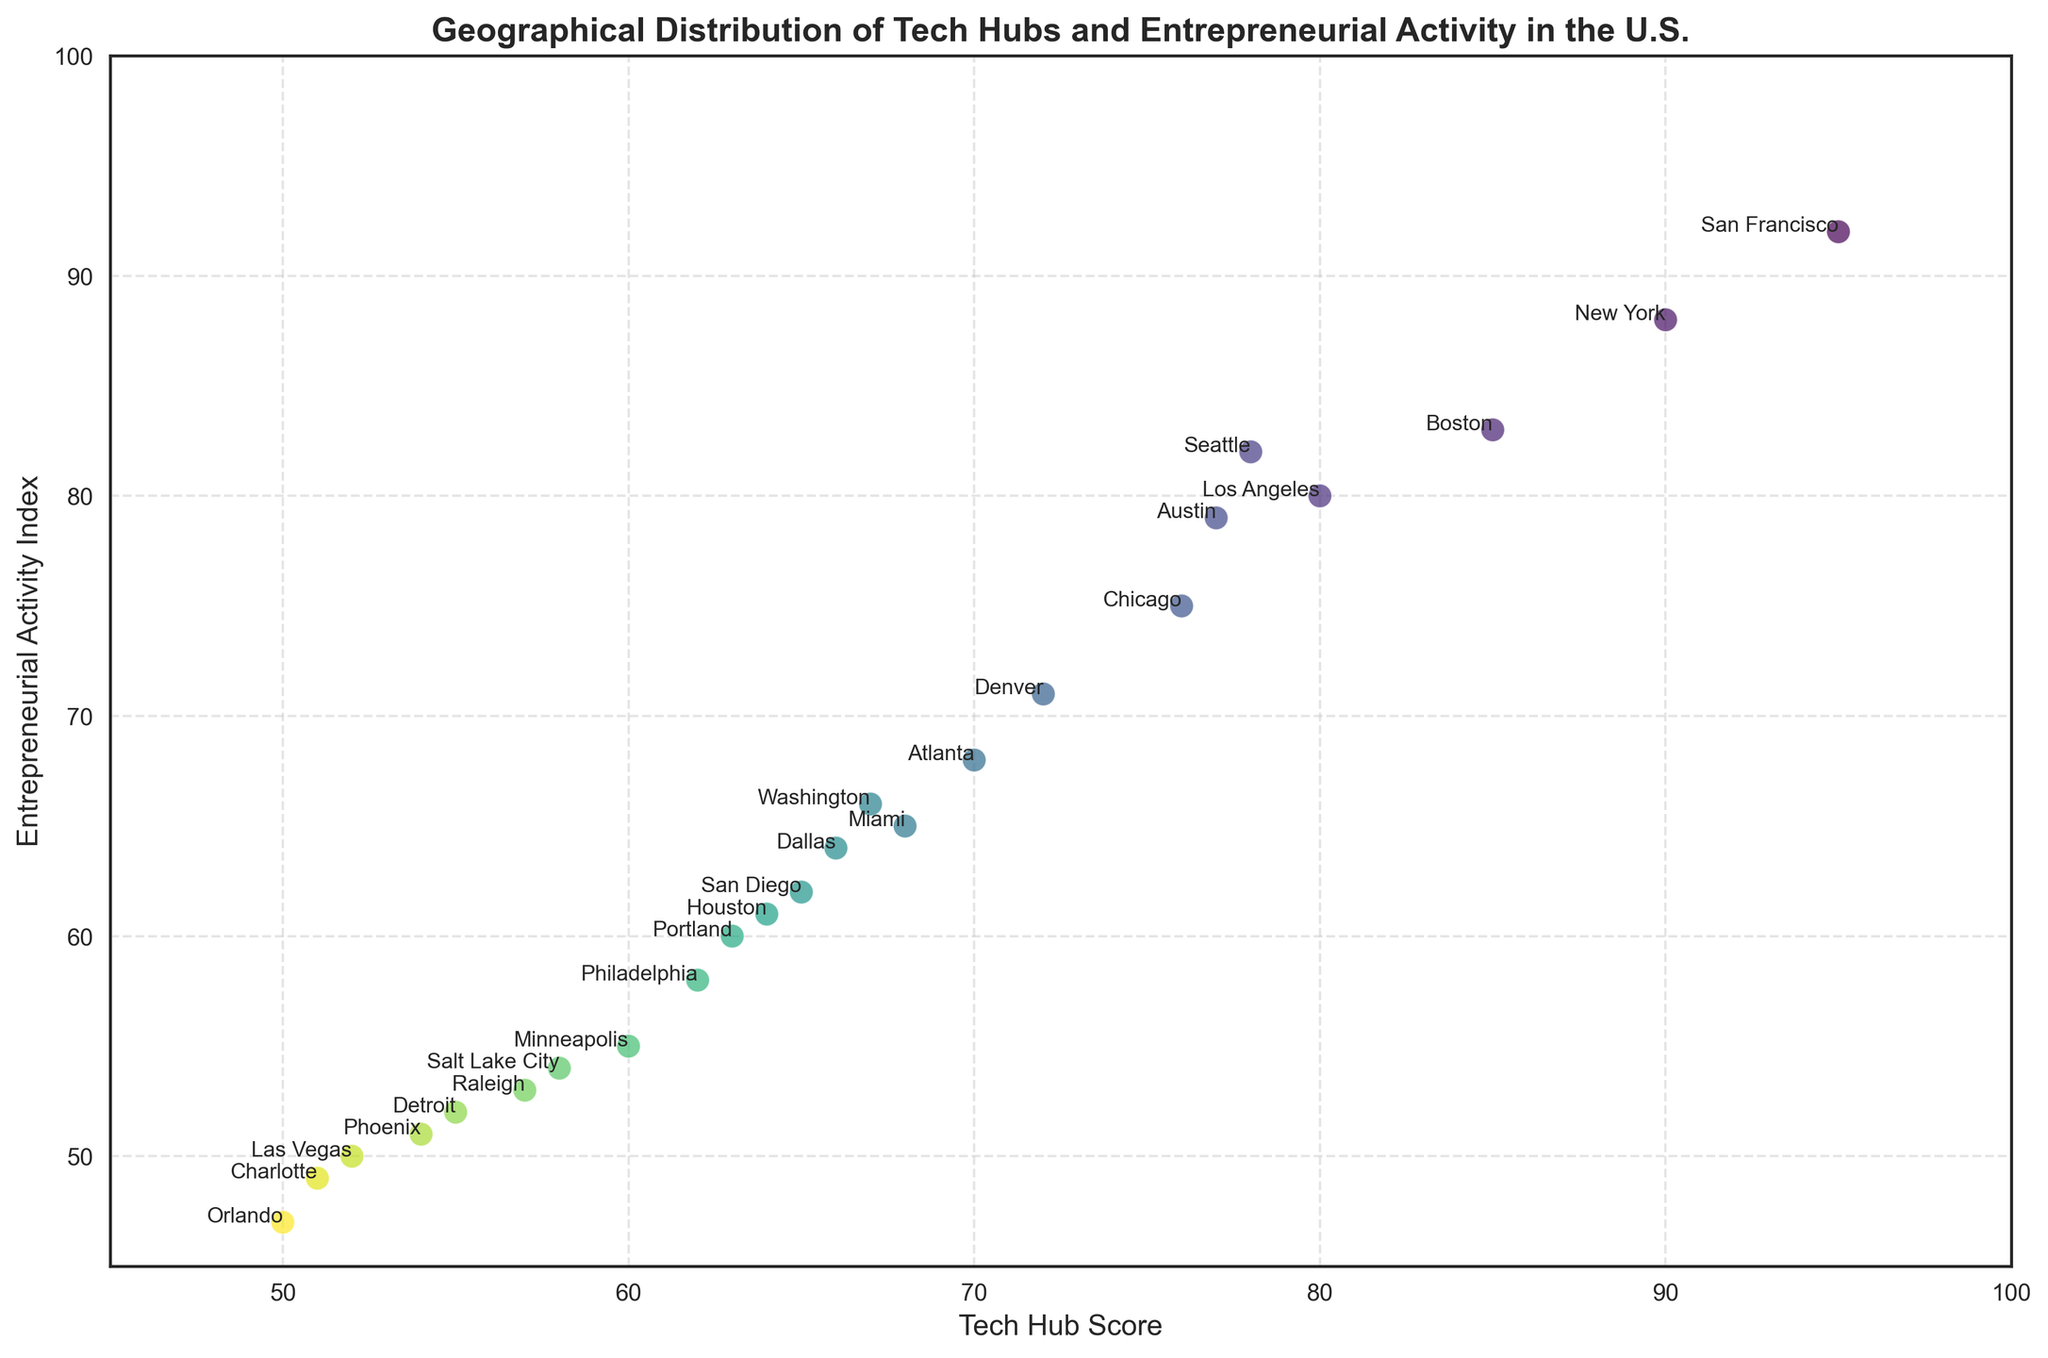Which city has the highest Tech Hub Score? The city names and their Tech Hub Scores are plotted on the figure. By identifying the highest point on the Tech Hub Score axis (x-axis), we can determine that San Francisco, CA has the highest score of 95.
Answer: San Francisco Which city has the lowest Entrepreneurial Activity Index? The city names and their Entrepreneurial Activity Indexes are plotted on the figure. By identifying the lowest point on the Entrepreneurial Activity Index axis (y-axis), we can determine that Orlando, FL has the lowest index of 47.
Answer: Orlando What is the average Tech Hub Score for the cities shown? Sum all the Tech Hub Scores and divide by the number of cities: (95 + 90 + 85 + 80 + 78 + 77 + 76 + 72 + 70 + 68 + 67 + 66 + 65 + 64 + 63 + 62 + 60 + 58 + 57 + 55 + 54 + 52 + 51 + 50) / 24.
Answer: 67.5 Which city has a higher Entrepreneurial Activity Index, Seattle, WA or Austin, TX? Compare their Entrepreneurial Activity Indexes on the y-axis: Seattle has 82, while Austin has 79.
Answer: Seattle Is there any city that has the same score for both Tech Hub Score and Entrepreneurial Activity Index? Look at the diagonal where Tech Hub Score equals Entrepreneurial Activity Index and find any city located on this line. Los Angeles, CA has scores of 80 for both.
Answer: Los Angeles What is the difference in Tech Hub Scores between Boston, MA and Phoenix, AZ? Subtract the Tech Hub Score of Phoenix (54) from Boston (85): 85 - 54.
Answer: 31 Which three cities have the highest Entrepreneurial Activity Indexes? Identify the cities at the top of the Entrepreneurial Activity Index axis: San Francisco, CA (92), New York, NY (88), and Boston, MA (83).
Answer: San Francisco, New York, Boston What is the sum of Entrepreneurial Activity Index scores for the cities in Texas (Austin, Dallas, Houston)? Add the Entrepreneurial Activity Index scores for Austin (79), Dallas (64), and Houston (61): 79 + 64 + 61.
Answer: 204 Which city falls closest to the mid-point (average) values of both Tech Hub Score and Entrepreneurial Activity Index? The mid-points are the averages of all scores. Tech Hub Score average is 67.5 and Entrepreneurial Activity Index average is 67. Find the nearest point: Washington, DC has scores of 67 and 66 respectively.
Answer: Washington, DC Is San Francisco, CA's Entrepreneurial Activity Index greater than Miami, FL's Tech Hub Score? Compare San Francisco's Entrepreneurial Activity Index (92) to Miami's Tech Hub Score (68). Since 92 > 68, the answer is yes.
Answer: Yes 